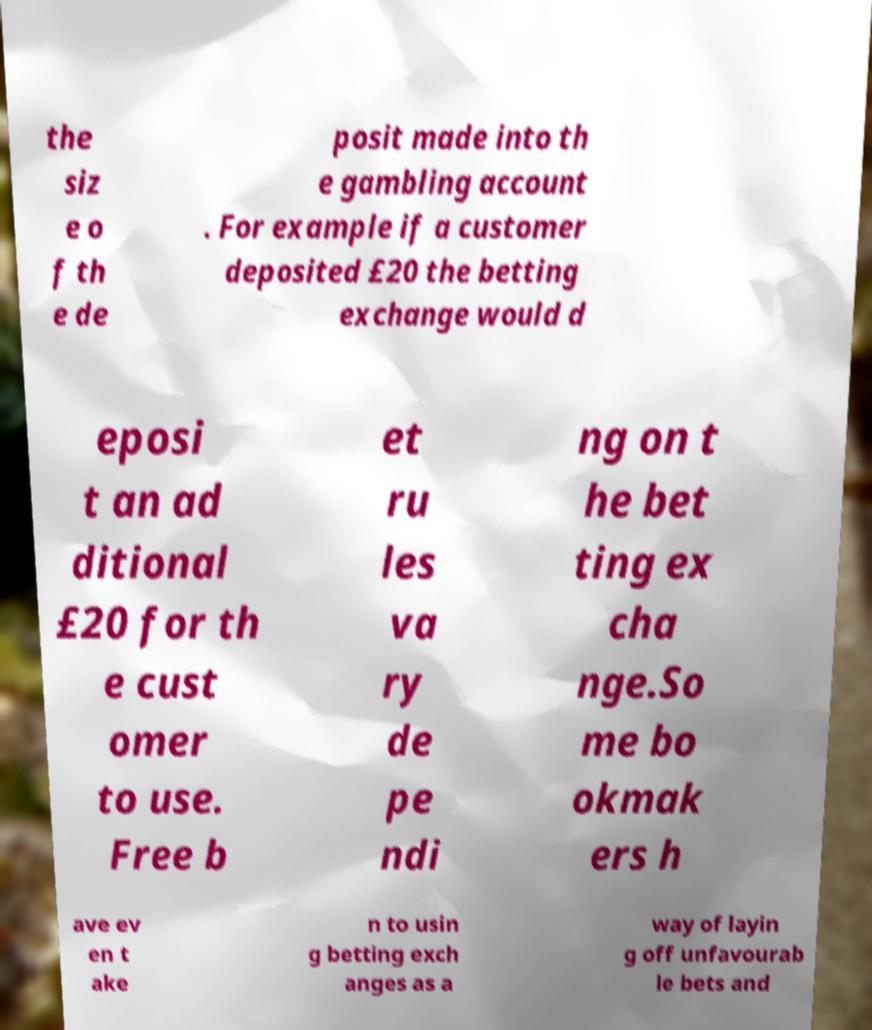There's text embedded in this image that I need extracted. Can you transcribe it verbatim? the siz e o f th e de posit made into th e gambling account . For example if a customer deposited £20 the betting exchange would d eposi t an ad ditional £20 for th e cust omer to use. Free b et ru les va ry de pe ndi ng on t he bet ting ex cha nge.So me bo okmak ers h ave ev en t ake n to usin g betting exch anges as a way of layin g off unfavourab le bets and 